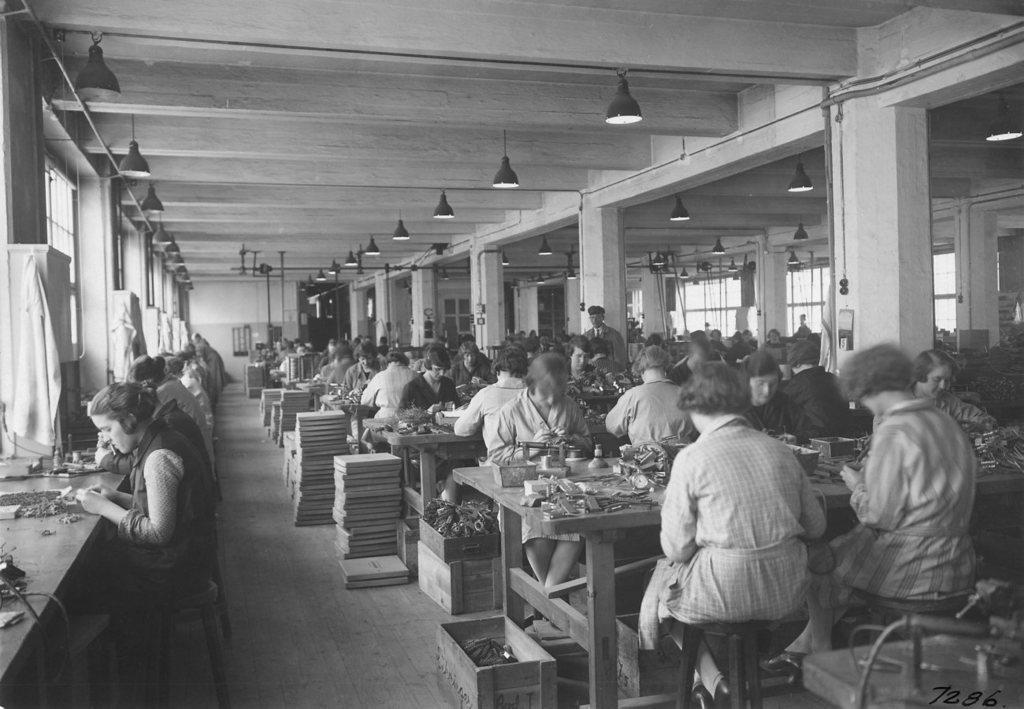Could you give a brief overview of what you see in this image? This is the picture of a place where we have some people sitting on the chairs in front of the table and working some thing and there are some lamps to the roof. 